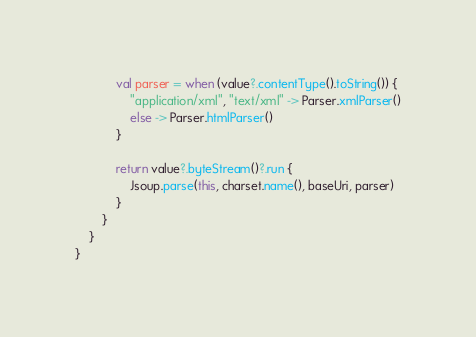<code> <loc_0><loc_0><loc_500><loc_500><_Kotlin_>            val parser = when (value?.contentType().toString()) {
                "application/xml", "text/xml" -> Parser.xmlParser()
                else -> Parser.htmlParser()
            }

            return value?.byteStream()?.run {
                Jsoup.parse(this, charset.name(), baseUri, parser)
            }
        }
    }
}
</code> 